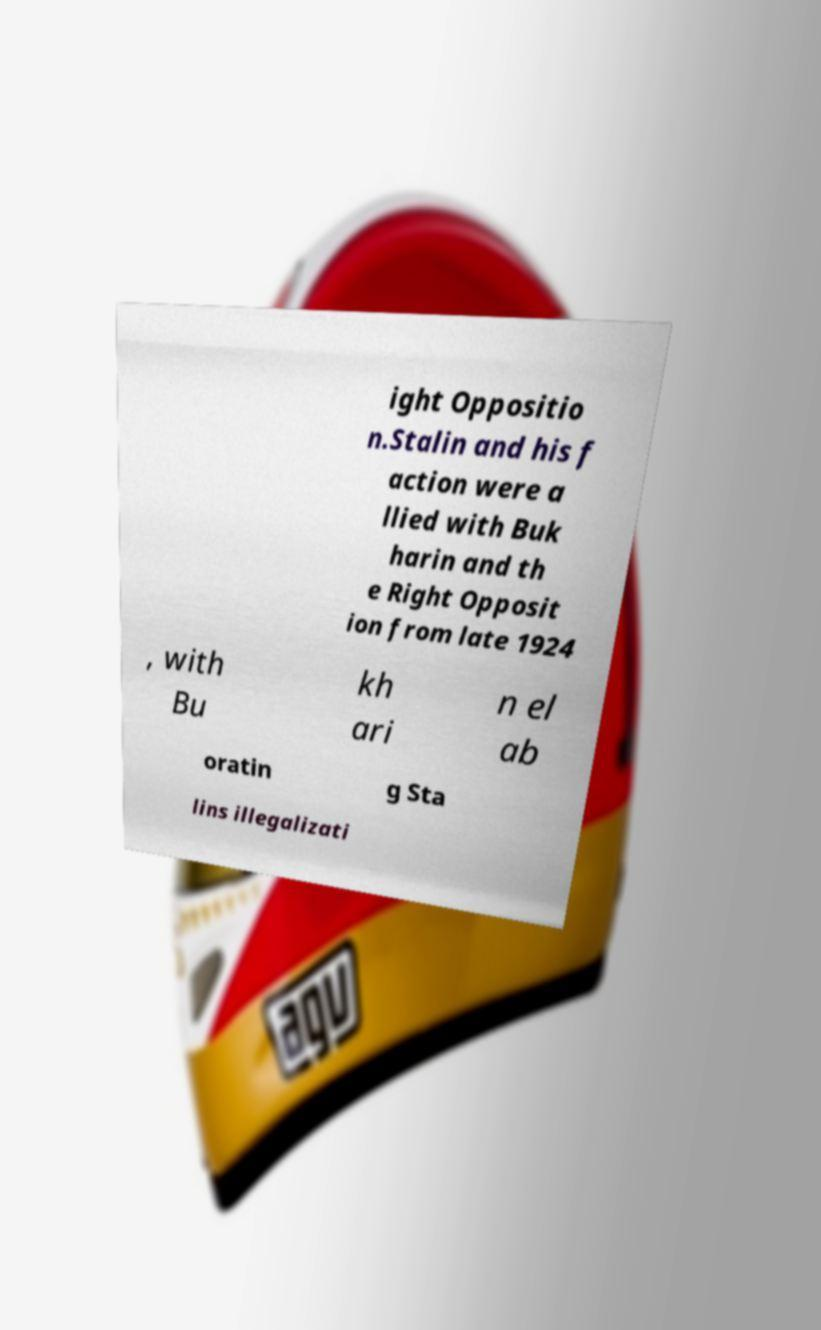Could you extract and type out the text from this image? ight Oppositio n.Stalin and his f action were a llied with Buk harin and th e Right Opposit ion from late 1924 , with Bu kh ari n el ab oratin g Sta lins illegalizati 